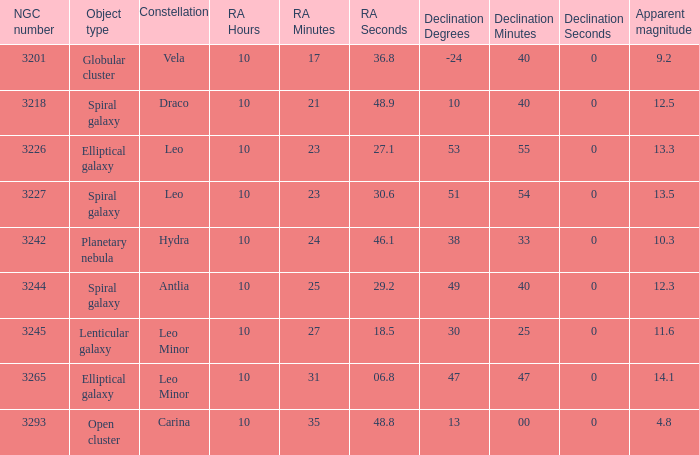What is the Apparent magnitude of a globular cluster? 9.2. 